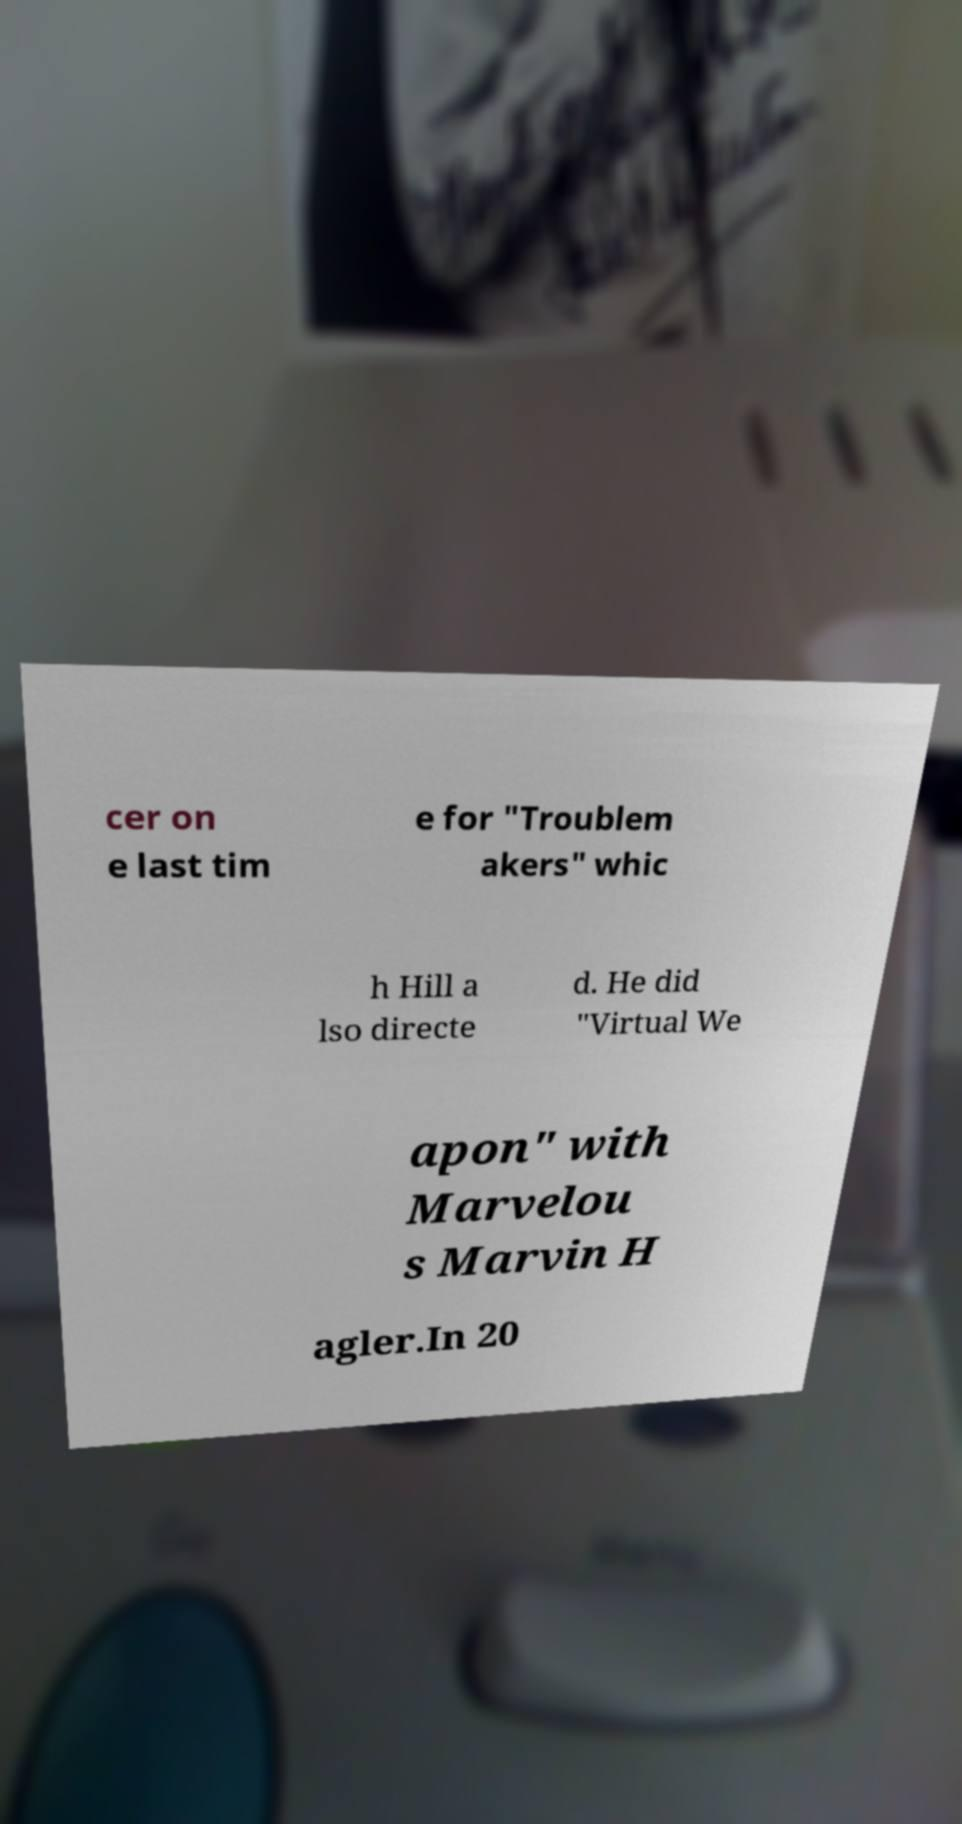Could you assist in decoding the text presented in this image and type it out clearly? cer on e last tim e for "Troublem akers" whic h Hill a lso directe d. He did "Virtual We apon" with Marvelou s Marvin H agler.In 20 